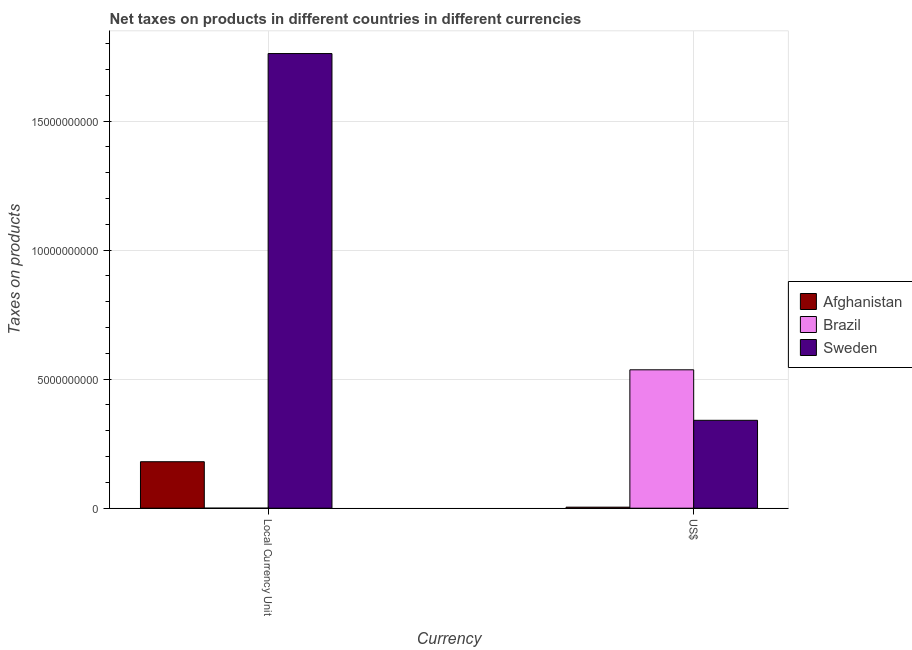Are the number of bars per tick equal to the number of legend labels?
Provide a succinct answer. Yes. How many bars are there on the 1st tick from the left?
Give a very brief answer. 3. How many bars are there on the 1st tick from the right?
Your answer should be very brief. 3. What is the label of the 2nd group of bars from the left?
Your answer should be compact. US$. What is the net taxes in constant 2005 us$ in Brazil?
Your answer should be very brief. 0.01. Across all countries, what is the maximum net taxes in us$?
Give a very brief answer. 5.36e+09. Across all countries, what is the minimum net taxes in us$?
Give a very brief answer. 4.00e+07. In which country was the net taxes in constant 2005 us$ maximum?
Your answer should be very brief. Sweden. In which country was the net taxes in constant 2005 us$ minimum?
Your answer should be compact. Brazil. What is the total net taxes in us$ in the graph?
Your answer should be very brief. 8.81e+09. What is the difference between the net taxes in constant 2005 us$ in Sweden and that in Afghanistan?
Offer a terse response. 1.58e+1. What is the difference between the net taxes in constant 2005 us$ in Afghanistan and the net taxes in us$ in Sweden?
Give a very brief answer. -1.60e+09. What is the average net taxes in us$ per country?
Your answer should be very brief. 2.94e+09. What is the difference between the net taxes in us$ and net taxes in constant 2005 us$ in Brazil?
Offer a terse response. 5.36e+09. What is the ratio of the net taxes in us$ in Afghanistan to that in Sweden?
Provide a short and direct response. 0.01. In how many countries, is the net taxes in constant 2005 us$ greater than the average net taxes in constant 2005 us$ taken over all countries?
Give a very brief answer. 1. How many bars are there?
Offer a terse response. 6. Are all the bars in the graph horizontal?
Your response must be concise. No. How many countries are there in the graph?
Provide a succinct answer. 3. What is the difference between two consecutive major ticks on the Y-axis?
Offer a terse response. 5.00e+09. Does the graph contain grids?
Your response must be concise. Yes. What is the title of the graph?
Make the answer very short. Net taxes on products in different countries in different currencies. Does "Paraguay" appear as one of the legend labels in the graph?
Your answer should be very brief. No. What is the label or title of the X-axis?
Your response must be concise. Currency. What is the label or title of the Y-axis?
Keep it short and to the point. Taxes on products. What is the Taxes on products of Afghanistan in Local Currency Unit?
Your answer should be very brief. 1.80e+09. What is the Taxes on products of Brazil in Local Currency Unit?
Provide a short and direct response. 0.01. What is the Taxes on products in Sweden in Local Currency Unit?
Your answer should be very brief. 1.76e+1. What is the Taxes on products in Afghanistan in US$?
Your answer should be compact. 4.00e+07. What is the Taxes on products of Brazil in US$?
Give a very brief answer. 5.36e+09. What is the Taxes on products of Sweden in US$?
Your answer should be compact. 3.40e+09. Across all Currency, what is the maximum Taxes on products in Afghanistan?
Offer a terse response. 1.80e+09. Across all Currency, what is the maximum Taxes on products in Brazil?
Ensure brevity in your answer.  5.36e+09. Across all Currency, what is the maximum Taxes on products in Sweden?
Your answer should be compact. 1.76e+1. Across all Currency, what is the minimum Taxes on products in Afghanistan?
Provide a succinct answer. 4.00e+07. Across all Currency, what is the minimum Taxes on products of Brazil?
Ensure brevity in your answer.  0.01. Across all Currency, what is the minimum Taxes on products in Sweden?
Offer a very short reply. 3.40e+09. What is the total Taxes on products of Afghanistan in the graph?
Keep it short and to the point. 1.84e+09. What is the total Taxes on products in Brazil in the graph?
Ensure brevity in your answer.  5.36e+09. What is the total Taxes on products in Sweden in the graph?
Your answer should be compact. 2.10e+1. What is the difference between the Taxes on products in Afghanistan in Local Currency Unit and that in US$?
Your answer should be compact. 1.76e+09. What is the difference between the Taxes on products of Brazil in Local Currency Unit and that in US$?
Provide a succinct answer. -5.36e+09. What is the difference between the Taxes on products of Sweden in Local Currency Unit and that in US$?
Provide a short and direct response. 1.42e+1. What is the difference between the Taxes on products in Afghanistan in Local Currency Unit and the Taxes on products in Brazil in US$?
Your answer should be very brief. -3.56e+09. What is the difference between the Taxes on products in Afghanistan in Local Currency Unit and the Taxes on products in Sweden in US$?
Keep it short and to the point. -1.60e+09. What is the difference between the Taxes on products in Brazil in Local Currency Unit and the Taxes on products in Sweden in US$?
Your response must be concise. -3.40e+09. What is the average Taxes on products of Afghanistan per Currency?
Keep it short and to the point. 9.20e+08. What is the average Taxes on products of Brazil per Currency?
Your answer should be very brief. 2.68e+09. What is the average Taxes on products of Sweden per Currency?
Your response must be concise. 1.05e+1. What is the difference between the Taxes on products in Afghanistan and Taxes on products in Brazil in Local Currency Unit?
Your answer should be compact. 1.80e+09. What is the difference between the Taxes on products in Afghanistan and Taxes on products in Sweden in Local Currency Unit?
Your answer should be compact. -1.58e+1. What is the difference between the Taxes on products in Brazil and Taxes on products in Sweden in Local Currency Unit?
Make the answer very short. -1.76e+1. What is the difference between the Taxes on products in Afghanistan and Taxes on products in Brazil in US$?
Give a very brief answer. -5.32e+09. What is the difference between the Taxes on products of Afghanistan and Taxes on products of Sweden in US$?
Provide a succinct answer. -3.36e+09. What is the difference between the Taxes on products of Brazil and Taxes on products of Sweden in US$?
Ensure brevity in your answer.  1.96e+09. What is the ratio of the Taxes on products in Afghanistan in Local Currency Unit to that in US$?
Provide a succinct answer. 45. What is the ratio of the Taxes on products of Sweden in Local Currency Unit to that in US$?
Your response must be concise. 5.17. What is the difference between the highest and the second highest Taxes on products of Afghanistan?
Ensure brevity in your answer.  1.76e+09. What is the difference between the highest and the second highest Taxes on products of Brazil?
Your response must be concise. 5.36e+09. What is the difference between the highest and the second highest Taxes on products in Sweden?
Your response must be concise. 1.42e+1. What is the difference between the highest and the lowest Taxes on products in Afghanistan?
Provide a succinct answer. 1.76e+09. What is the difference between the highest and the lowest Taxes on products of Brazil?
Provide a short and direct response. 5.36e+09. What is the difference between the highest and the lowest Taxes on products in Sweden?
Provide a short and direct response. 1.42e+1. 